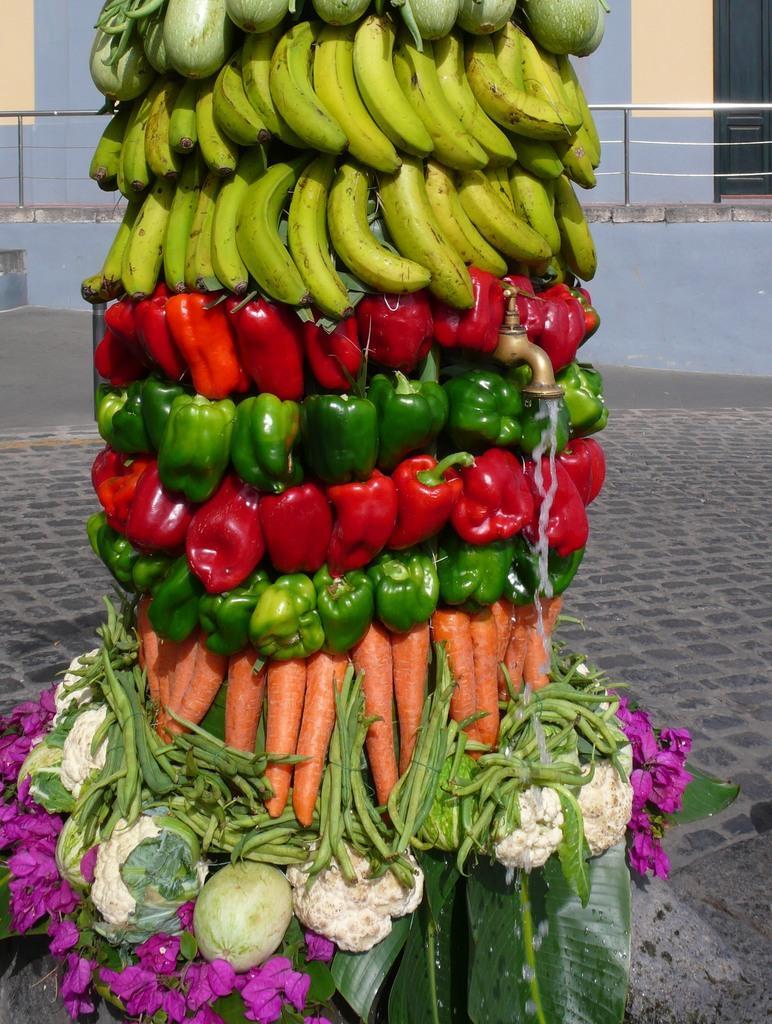How would you summarize this image in a sentence or two? In this picture we can see flowers, leaves, carrots, capsicums, bananas, cauliflowers, tap and in the background we can see the floor, fence. 